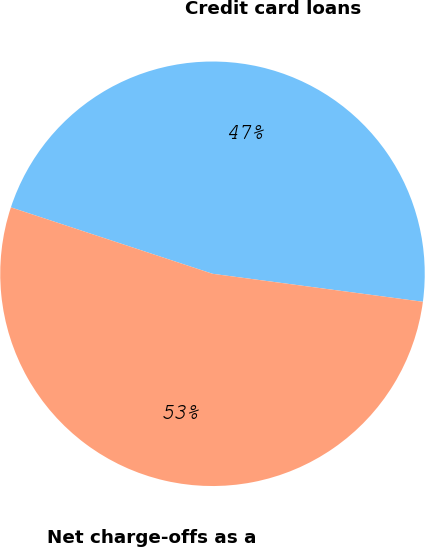Convert chart. <chart><loc_0><loc_0><loc_500><loc_500><pie_chart><fcel>Credit card loans<fcel>Net charge-offs as a<nl><fcel>47.04%<fcel>52.96%<nl></chart> 